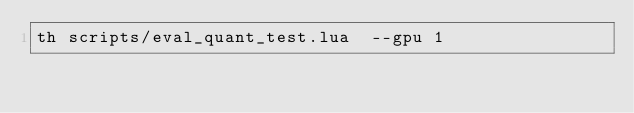<code> <loc_0><loc_0><loc_500><loc_500><_Bash_>th scripts/eval_quant_test.lua  --gpu 1

</code> 